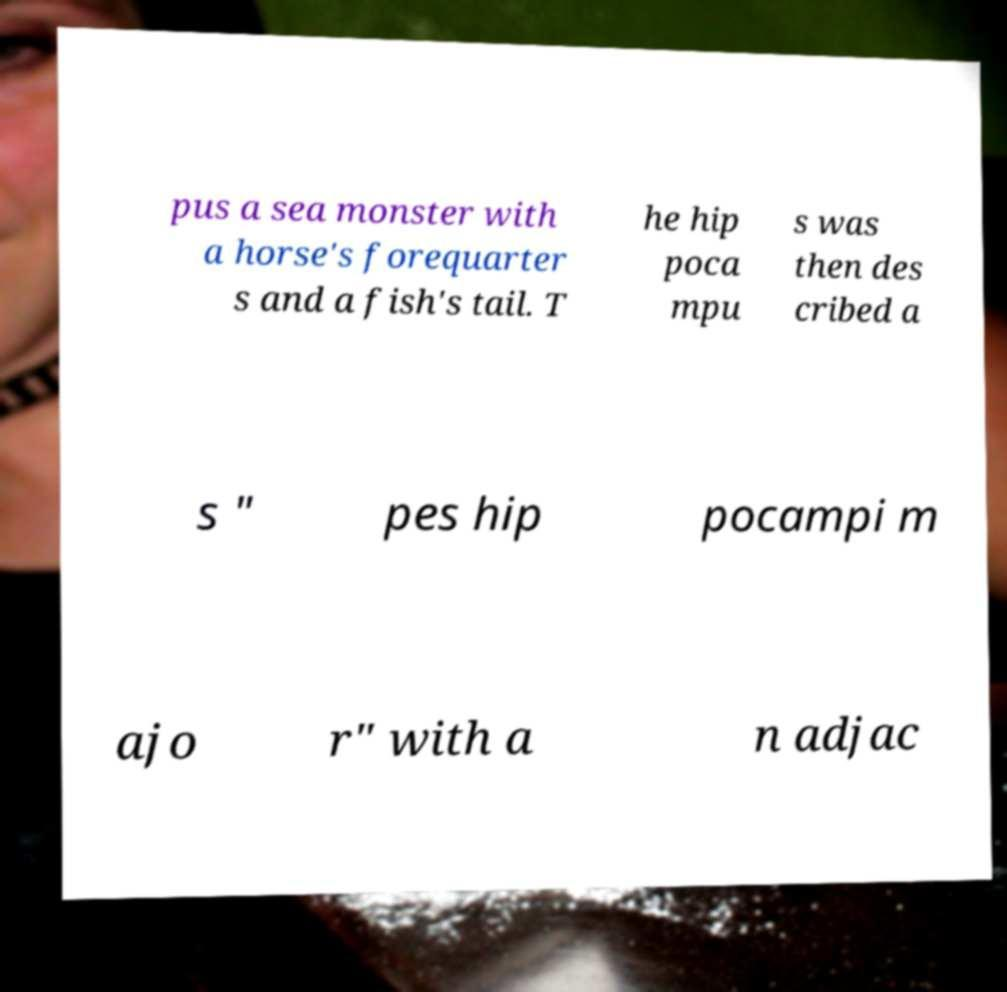Can you accurately transcribe the text from the provided image for me? pus a sea monster with a horse's forequarter s and a fish's tail. T he hip poca mpu s was then des cribed a s " pes hip pocampi m ajo r" with a n adjac 